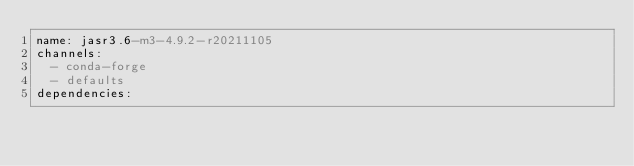Convert code to text. <code><loc_0><loc_0><loc_500><loc_500><_YAML_>name: jasr3.6-m3-4.9.2-r20211105
channels:
  - conda-forge
  - defaults
dependencies:
</code> 